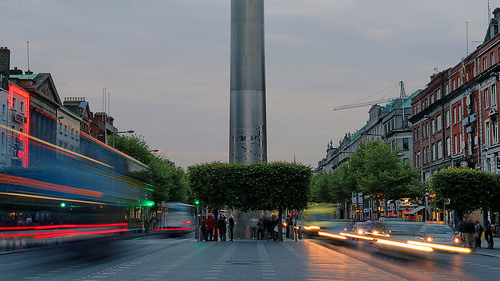<image>
Is the girl behind the guy? Yes. From this viewpoint, the girl is positioned behind the guy, with the guy partially or fully occluding the girl. 